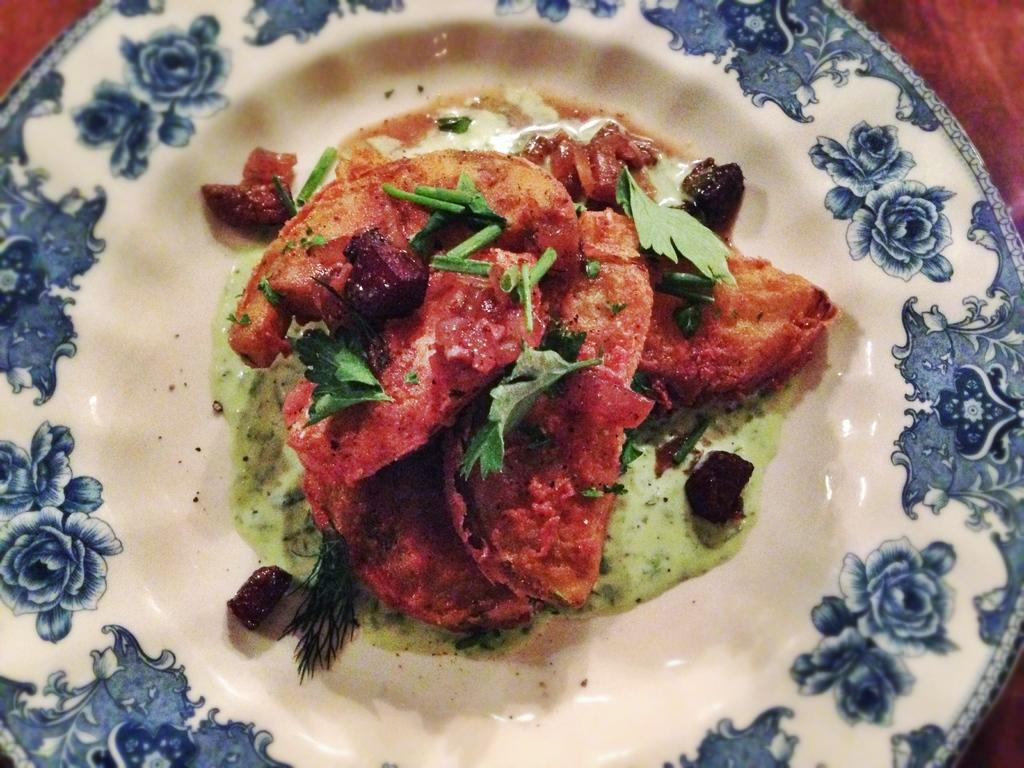What is on the plate that is visible in the image? The plate has food in it. What can be seen on the plate besides the food? The plate is painted with a design. What type of design is featured on the plate? The design features flowers. What type of shoes can be seen in the image? There are no shoes present in the image. What type of drink is being served in the image? There is no drink present in the image. 